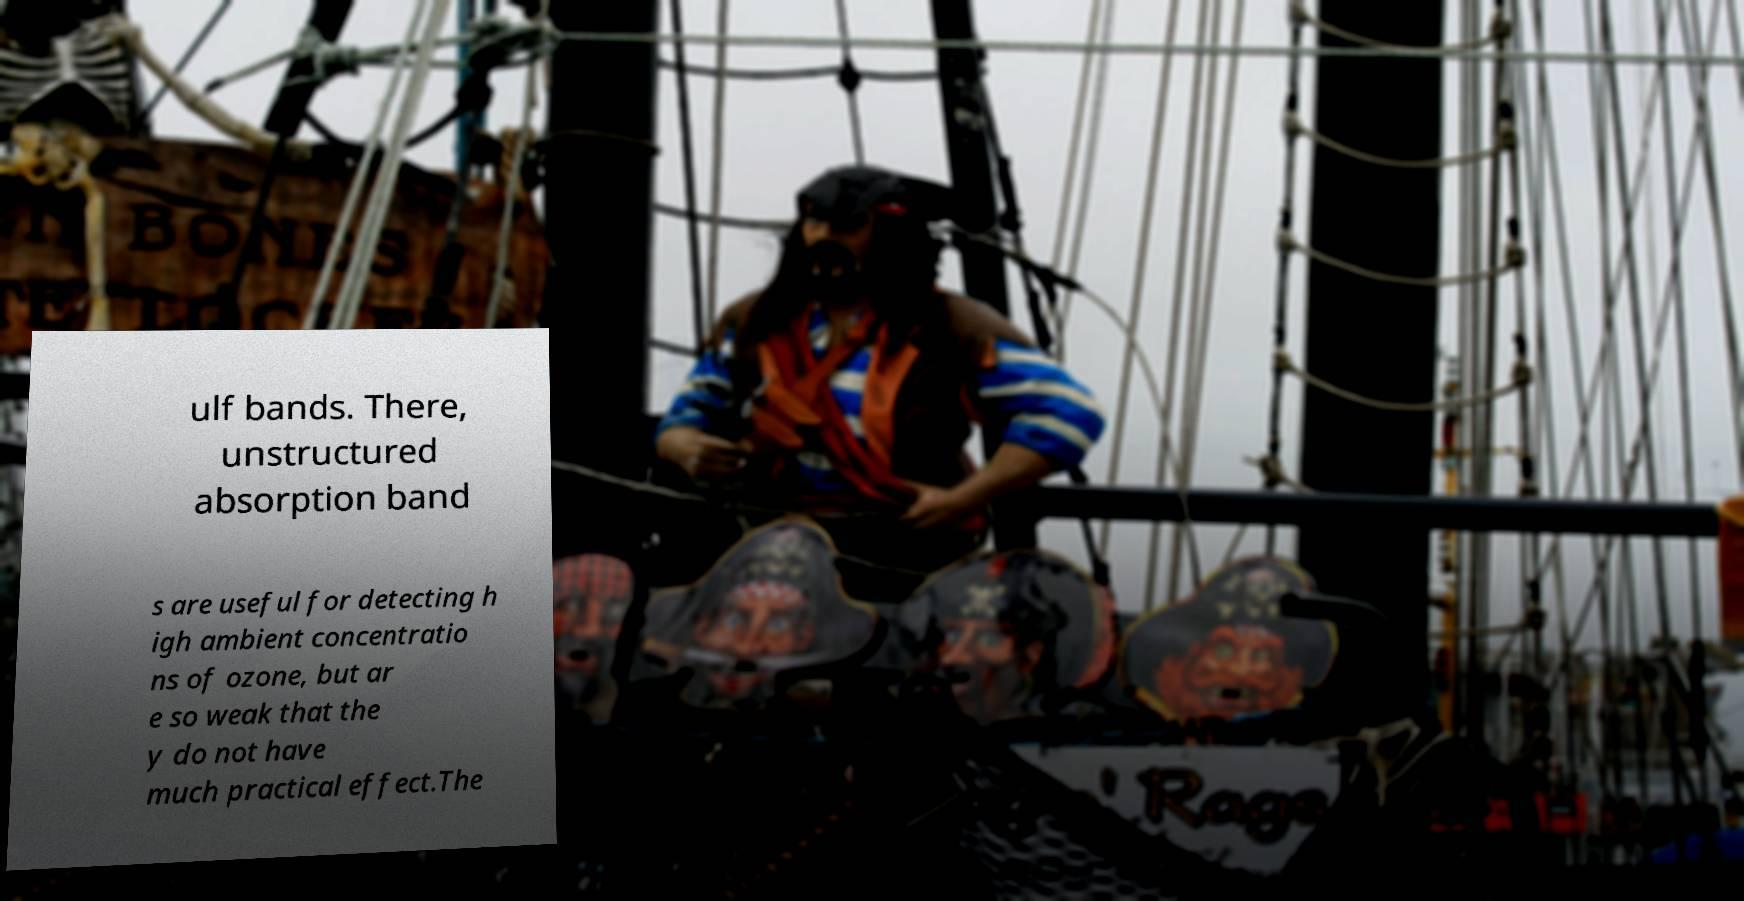Could you extract and type out the text from this image? ulf bands. There, unstructured absorption band s are useful for detecting h igh ambient concentratio ns of ozone, but ar e so weak that the y do not have much practical effect.The 